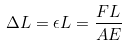Convert formula to latex. <formula><loc_0><loc_0><loc_500><loc_500>\Delta L = \epsilon L = \frac { F L } { A E }</formula> 